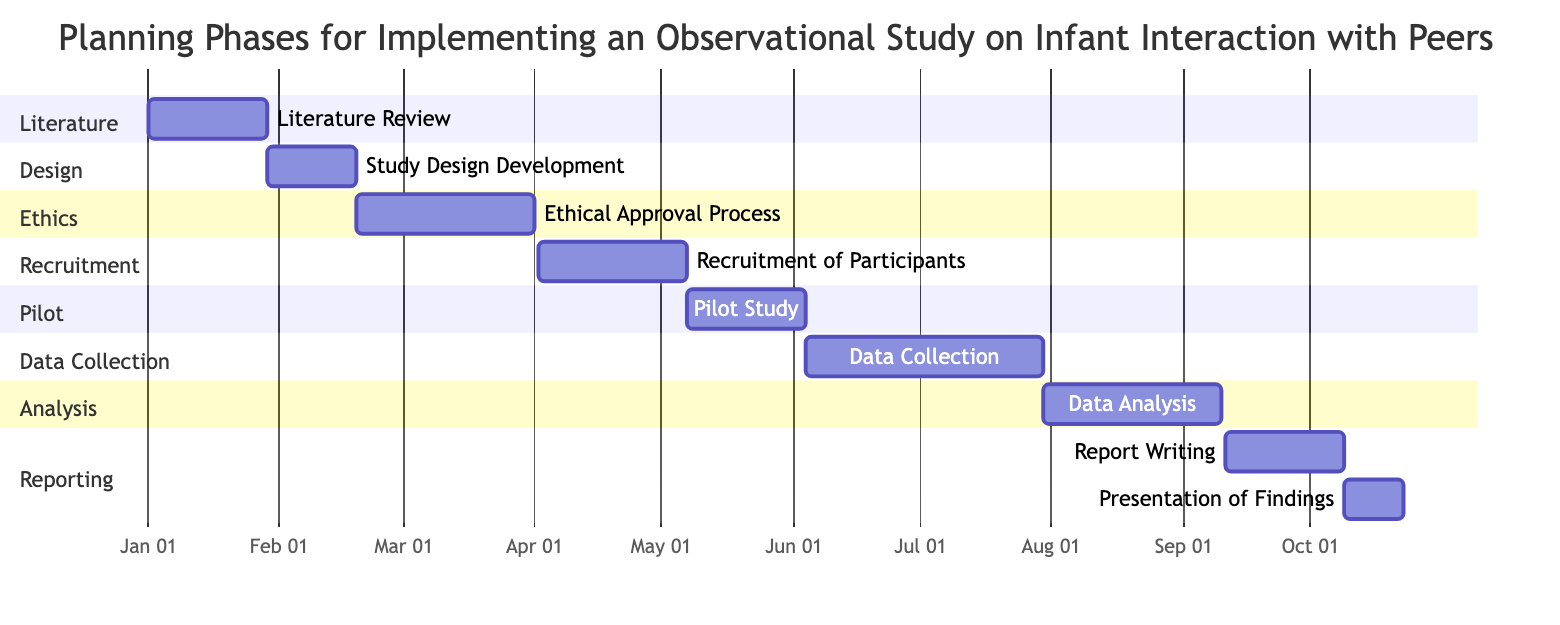What is the duration of the Literature Review phase? The Literature Review task is marked as lasting for '4 weeks' in the diagram.
Answer: 4 weeks When does the Study Design Development phase begin? The Start Date for the Study Design Development is specified as '2024-01-29' in the diagram.
Answer: 2024-01-29 How many weeks does the Data Collection phase last? The Data Collection task is indicated to last for '8 weeks' in the diagram.
Answer: 8 weeks What task immediately follows the Ethical Approval Process? The task immediately following the Ethical Approval Process is the 'Recruitment of Participants', as visible in the timeline sequence.
Answer: Recruitment of Participants What is the total number of distinct phases represented in the diagram? There are eight distinct phases labeled in the Gantt chart: Literature, Design, Ethics, Recruitment, Pilot, Data Collection, Analysis, and Reporting.
Answer: 8 How long is the time span from the start of the Pilot Study to the end of the Data Analysis phase? The Pilot Study starts on '2024-05-07' and ends on '2024-06-03', while Data Analysis starts on '2024-07-30' and ends on '2024-09-10'. Therefore, counting from the end of the Pilot Study to the end of Data Analysis gives a total span of 10 weeks.
Answer: 10 weeks What is the end date for the Report Writing task? The Report Writing task is concluded on '2024-10-08' as indicated in the Gantt chart.
Answer: 2024-10-08 Which task has the shortest duration within the chart? The task 'Presentation of Findings' has the shortest duration, lasting only '2 weeks'. This is observed by comparing the durations of all tasks in the diagram.
Answer: 2 weeks 